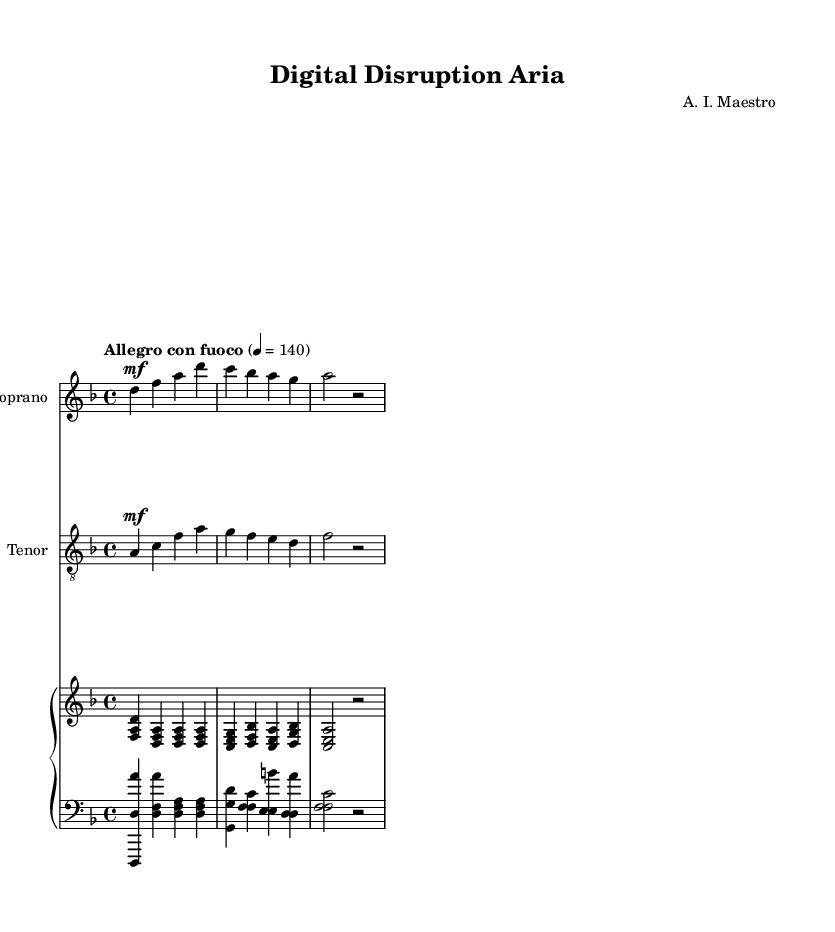What is the key signature of this music? The key signature is indicated at the beginning of the staff. In this case, it shows two flats (B♭ and E♭), which means it is in D minor or F major. Here, the first note is D, confirming the key of D minor.
Answer: D minor What is the time signature of this piece? The time signature is represented at the beginning of the sheet music. The fraction shows 4 beats in a measure with each quarter note getting one beat. Therefore, this is 4/4 time.
Answer: 4/4 What is the tempo marking for this music? The tempo is marked at the beginning with "Allegro con fuoco," which suggests a lively and spirited pace, typically around 120 to 168 bpm. Here it is specifically noted as 140.
Answer: Allegro con fuoco How many measures are there in the soprano part? To find the number of measures, you count the distinct groups of notes separated by vertical lines (bar lines). The soprano part shows four measures.
Answer: 4 Which voice has the lyrics reflecting traditional advertising? Looking at the lyrics assigned to the soprano part, it includes "Print ads reign supreme, tradition's might!" which clearly refers to traditional advertising methods.
Answer: Soprano What is the relationship between the tenor and soprano parts in terms of harmony? The tenor part is generally harmonizing with the soprano but often provides a counter-melody, adding depth and richness to the whole piece, a characteristic feature of opera duets.
Answer: Harmonizing Which instrument provides the accompaniment in this aria? The accompaniment is indicated by the presence of a piano staff at the bottom of the sheet music, showing that the piano plays a significant role in supporting the voices.
Answer: Piano 